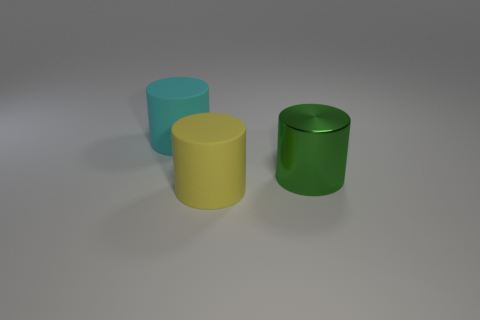There is a large object that is behind the large yellow matte cylinder and in front of the cyan cylinder; what shape is it?
Keep it short and to the point. Cylinder. Do the yellow matte thing and the green metallic object have the same size?
Keep it short and to the point. Yes. There is a large cyan cylinder; how many large yellow matte cylinders are in front of it?
Offer a very short reply. 1. Are there an equal number of large yellow cylinders that are on the left side of the cyan thing and cylinders that are behind the large green metal cylinder?
Your answer should be very brief. No. There is a big matte thing in front of the big cyan matte object; is its shape the same as the large metallic thing?
Offer a very short reply. Yes. Is there any other thing that is the same material as the green cylinder?
Provide a succinct answer. No. What number of other objects are the same color as the metallic thing?
Provide a short and direct response. 0. Are there any rubber cylinders in front of the shiny thing?
Provide a succinct answer. Yes. How many objects are either yellow matte cylinders or large things to the right of the yellow rubber cylinder?
Provide a short and direct response. 2. There is a cylinder on the right side of the yellow cylinder; is there a large yellow rubber thing that is in front of it?
Give a very brief answer. Yes. 